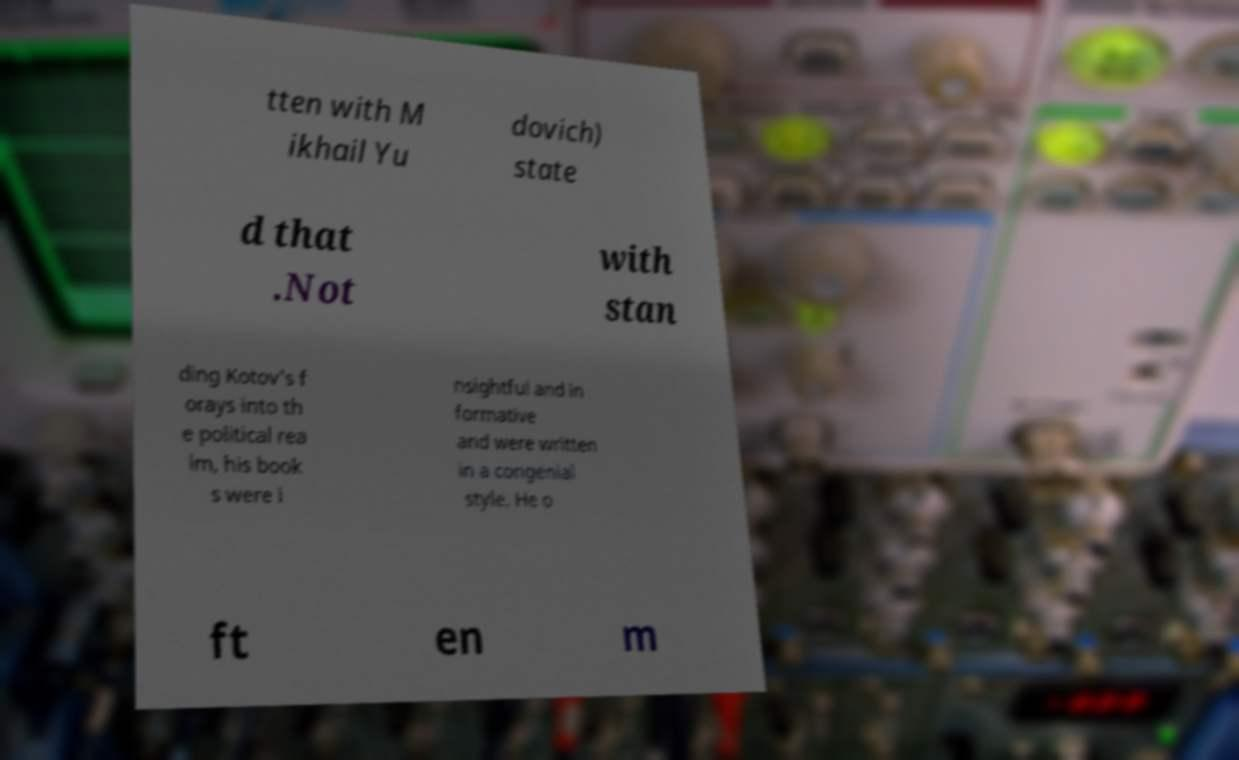For documentation purposes, I need the text within this image transcribed. Could you provide that? tten with M ikhail Yu dovich) state d that .Not with stan ding Kotov's f orays into th e political rea lm, his book s were i nsightful and in formative and were written in a congenial style. He o ft en m 